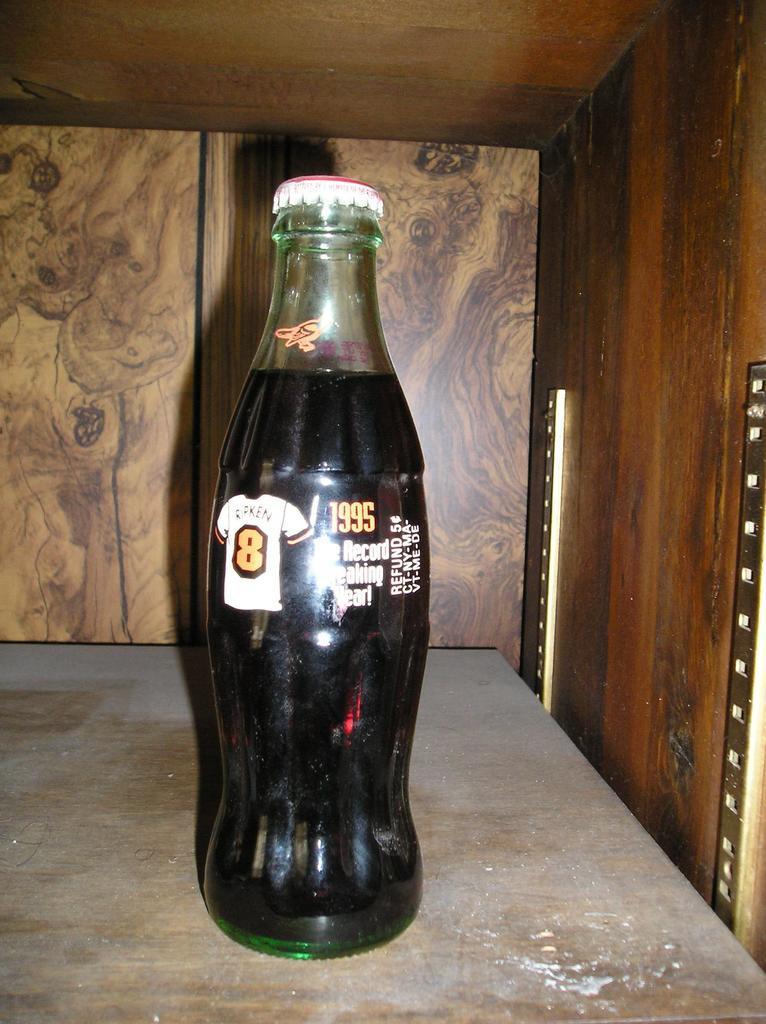Please provide a concise description of this image. In this image I can see a glass bottle on the wooden table. 